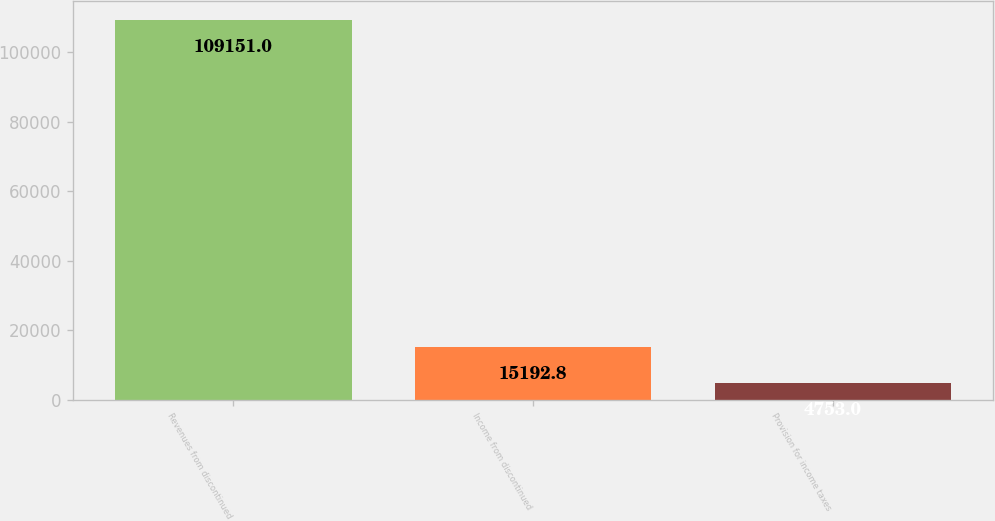Convert chart. <chart><loc_0><loc_0><loc_500><loc_500><bar_chart><fcel>Revenues from discontinued<fcel>Income from discontinued<fcel>Provision for income taxes<nl><fcel>109151<fcel>15192.8<fcel>4753<nl></chart> 